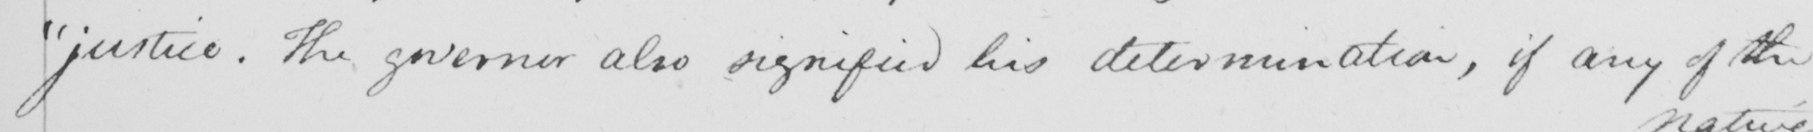Please provide the text content of this handwritten line. "justice. The governor also signified his determination, if any of the 